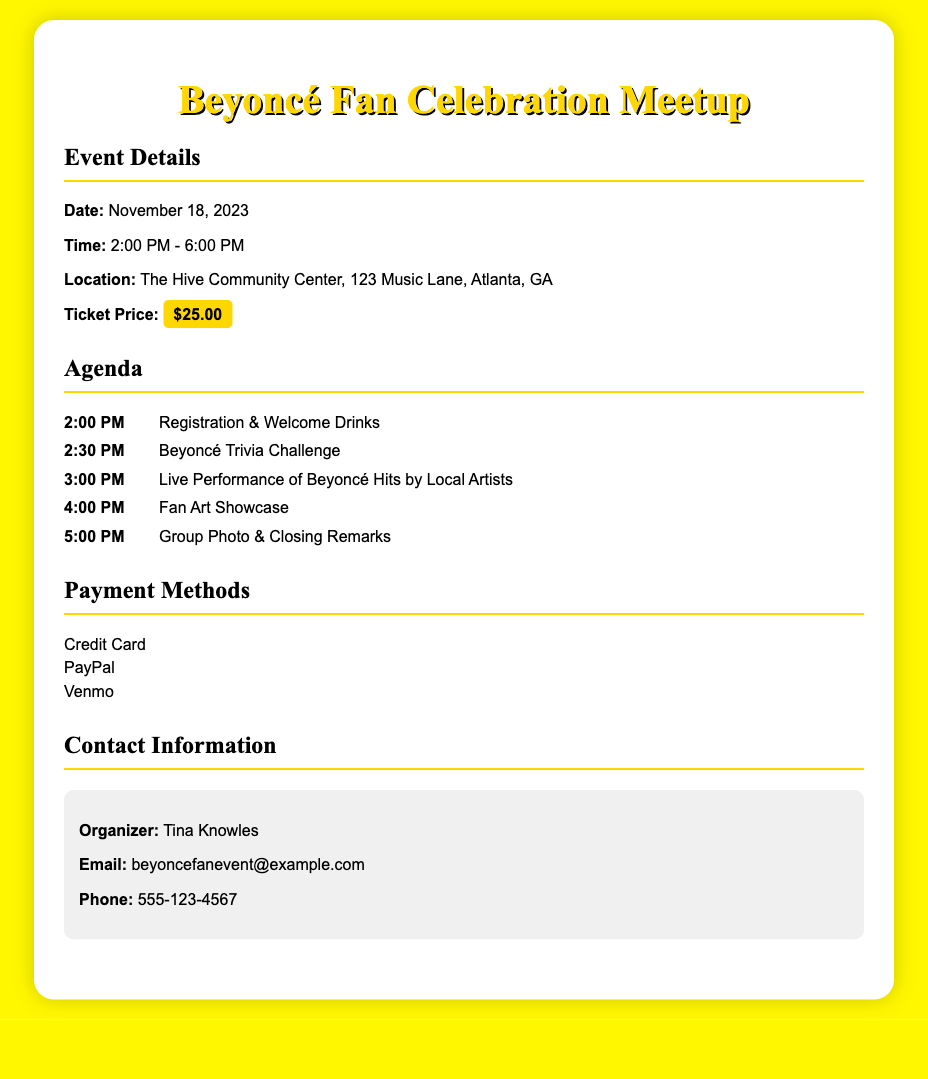what is the date of the event? The date of the event is explicitly stated in the document as November 18, 2023.
Answer: November 18, 2023 what time does the event start? The starting time of the event is mentioned in the document as 2:00 PM.
Answer: 2:00 PM how much is the ticket price? The ticket price is highlighted in the document, listed as $25.00.
Answer: $25.00 who is the organizer of the event? The organizer's name is provided in the contact section as Tina Knowles.
Answer: Tina Knowles what activity begins at 3:00 PM? The document states that a live performance of Beyoncé hits by local artists occurs at 3:00 PM.
Answer: Live Performance of Beyoncé Hits by Local Artists which payment methods are accepted? The document lists the accepted payment methods, which include Credit Card, PayPal, and Venmo.
Answer: Credit Card, PayPal, Venmo what is the location of the event? The location where the event will take place is specified as The Hive Community Center, 123 Music Lane, Atlanta, GA.
Answer: The Hive Community Center, 123 Music Lane, Atlanta, GA what is the last agenda item? The last agenda item mentioned in the document is Group Photo & Closing Remarks, scheduled for 5:00 PM.
Answer: Group Photo & Closing Remarks at what time is the Beyoncé Trivia Challenge scheduled? The document indicates that the Beyoncé Trivia Challenge is scheduled at 2:30 PM.
Answer: 2:30 PM 